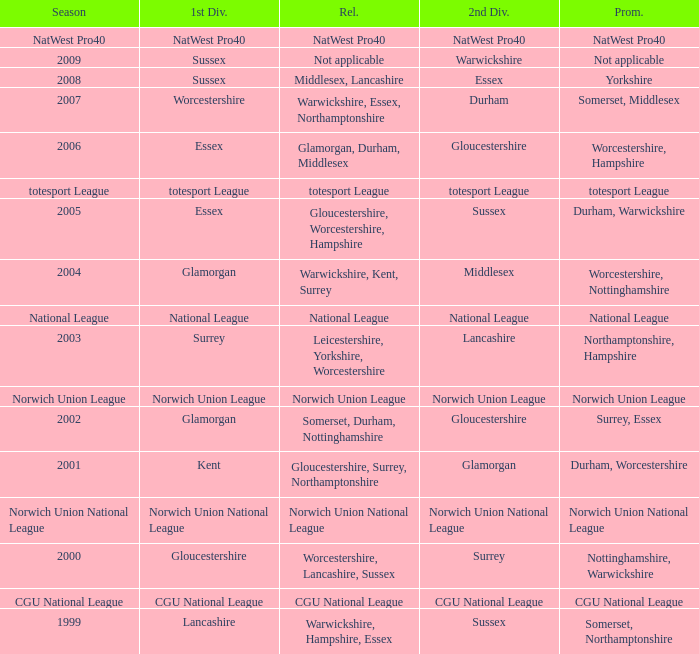What was relegated in the 2006 season? Glamorgan, Durham, Middlesex. 